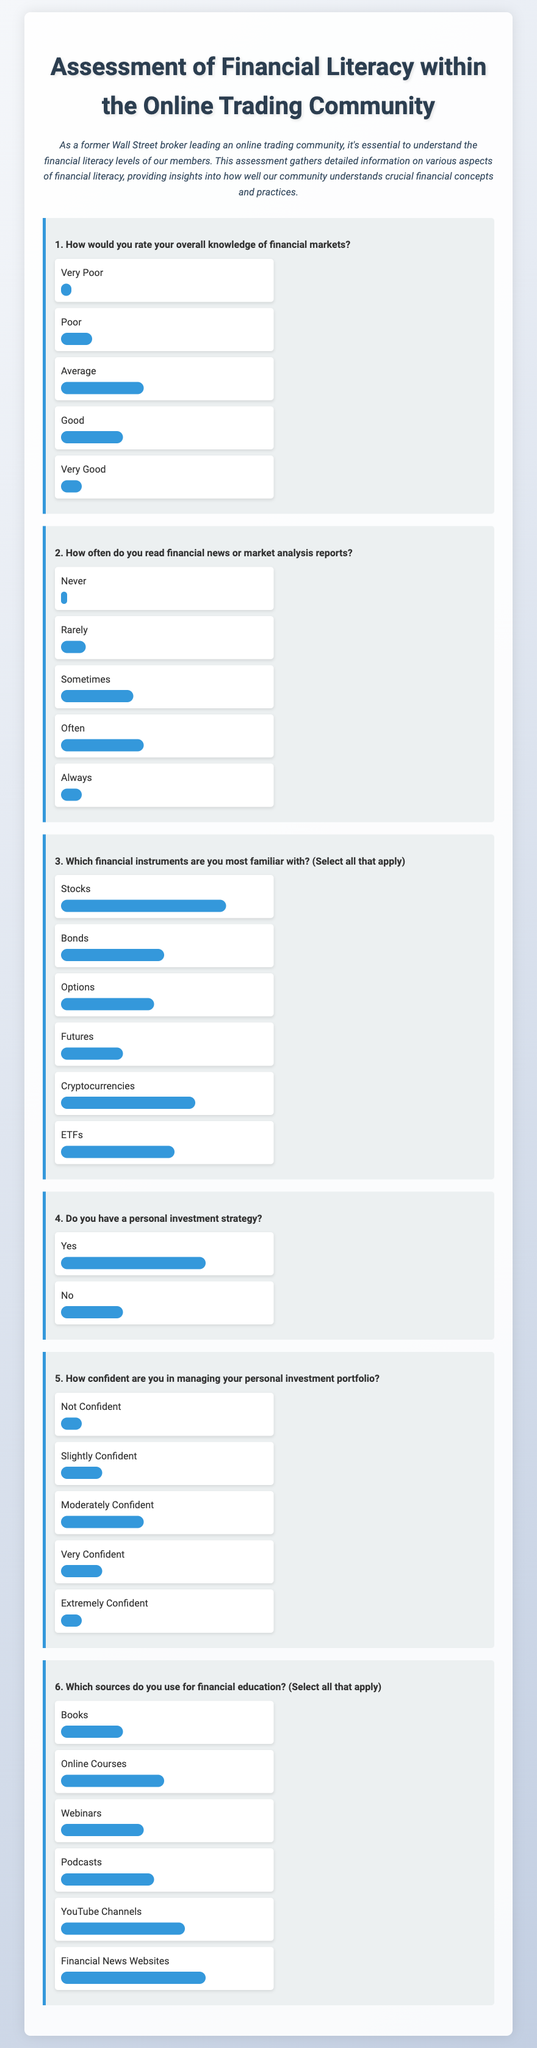What percentage of respondents rated their overall knowledge of financial markets as "Good"? The document shows a bar indicating that 30% of respondents rated their overall knowledge of financial markets as "Good."
Answer: 30% Which financial instrument had the highest familiarity among respondents? The document indicates that 80% of respondents are most familiar with "Stocks," which is represented by the longest bar.
Answer: Stocks How often do the majority of respondents read financial news or market analysis reports? The largest bar in the options indicates that the majority, at 40%, answer "Often" to reading financial news or market analysis reports.
Answer: Often What is the percentage of respondents who do not have a personal investment strategy? The document states that 30% of respondents answered "No" to having a personal investment strategy, as indicated by the bar's length.
Answer: 30% What source of financial education is used by the highest percentage of respondents? According to the document, "Financial News Websites" are used by 70% of respondents, which has the highest bar length among education sources.
Answer: Financial News Websites What proportion of respondents feel "Not Confident" in managing their personal investment portfolio? The document shows that 10% of respondents selected "Not Confident," reflected by the short bar under that option.
Answer: 10% Which financial instrument is the second most familiar after stocks? The document indicates that "Bonds" have the second highest familiarity level, with 50% of respondents indicating familiarity with them.
Answer: Bonds How many sources do respondents predominantly use for financial education? The document lists multiple sources, with the highest being Financial News Websites, along with various others, but does not specify a total count in the options.
Answer: Multiple sources 